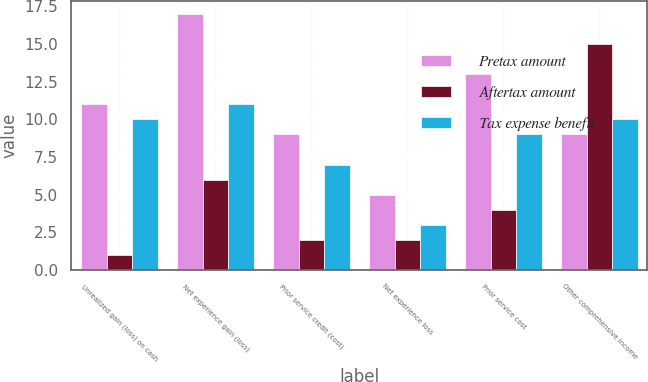Convert chart. <chart><loc_0><loc_0><loc_500><loc_500><stacked_bar_chart><ecel><fcel>Unrealized gain (loss) on cash<fcel>Net experience gain (loss)<fcel>Prior service credit (cost)<fcel>Net experience loss<fcel>Prior service cost<fcel>Other comprehensive income<nl><fcel>Pretax amount<fcel>11<fcel>17<fcel>9<fcel>5<fcel>13<fcel>9<nl><fcel>Aftertax amount<fcel>1<fcel>6<fcel>2<fcel>2<fcel>4<fcel>15<nl><fcel>Tax expense benefit<fcel>10<fcel>11<fcel>7<fcel>3<fcel>9<fcel>10<nl></chart> 